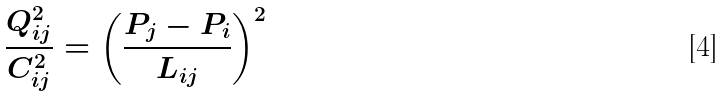<formula> <loc_0><loc_0><loc_500><loc_500>\frac { Q _ { i j } ^ { 2 } } { C _ { i j } ^ { 2 } } = \left ( \frac { P _ { j } - P _ { i } } { L _ { i j } } \right ) ^ { 2 }</formula> 